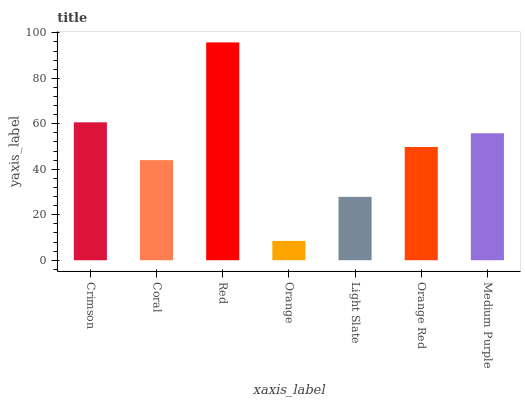Is Orange the minimum?
Answer yes or no. Yes. Is Red the maximum?
Answer yes or no. Yes. Is Coral the minimum?
Answer yes or no. No. Is Coral the maximum?
Answer yes or no. No. Is Crimson greater than Coral?
Answer yes or no. Yes. Is Coral less than Crimson?
Answer yes or no. Yes. Is Coral greater than Crimson?
Answer yes or no. No. Is Crimson less than Coral?
Answer yes or no. No. Is Orange Red the high median?
Answer yes or no. Yes. Is Orange Red the low median?
Answer yes or no. Yes. Is Red the high median?
Answer yes or no. No. Is Medium Purple the low median?
Answer yes or no. No. 